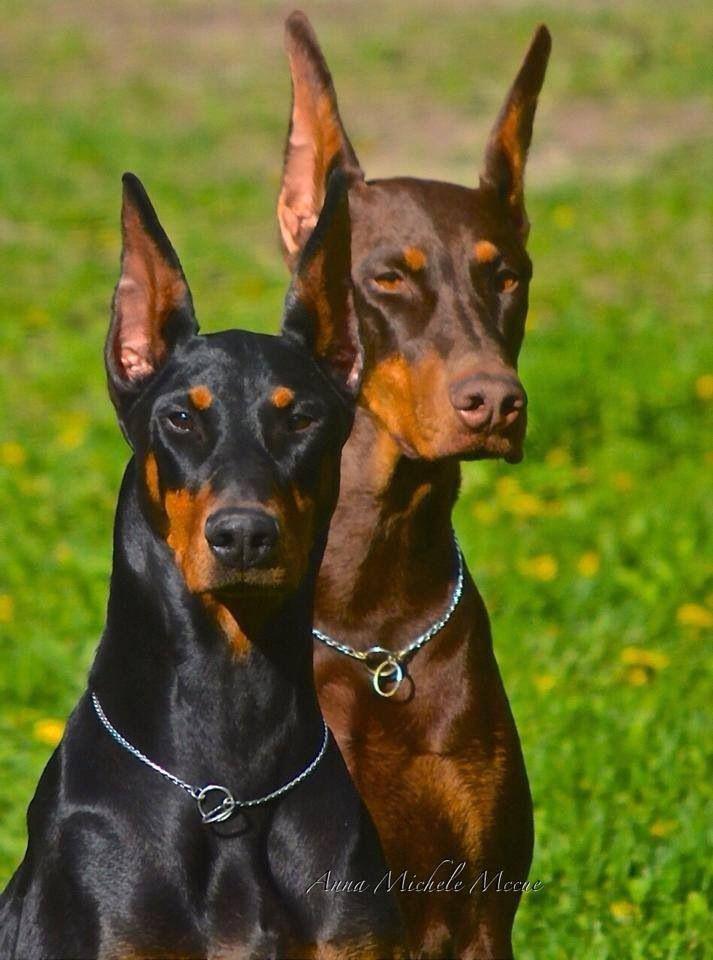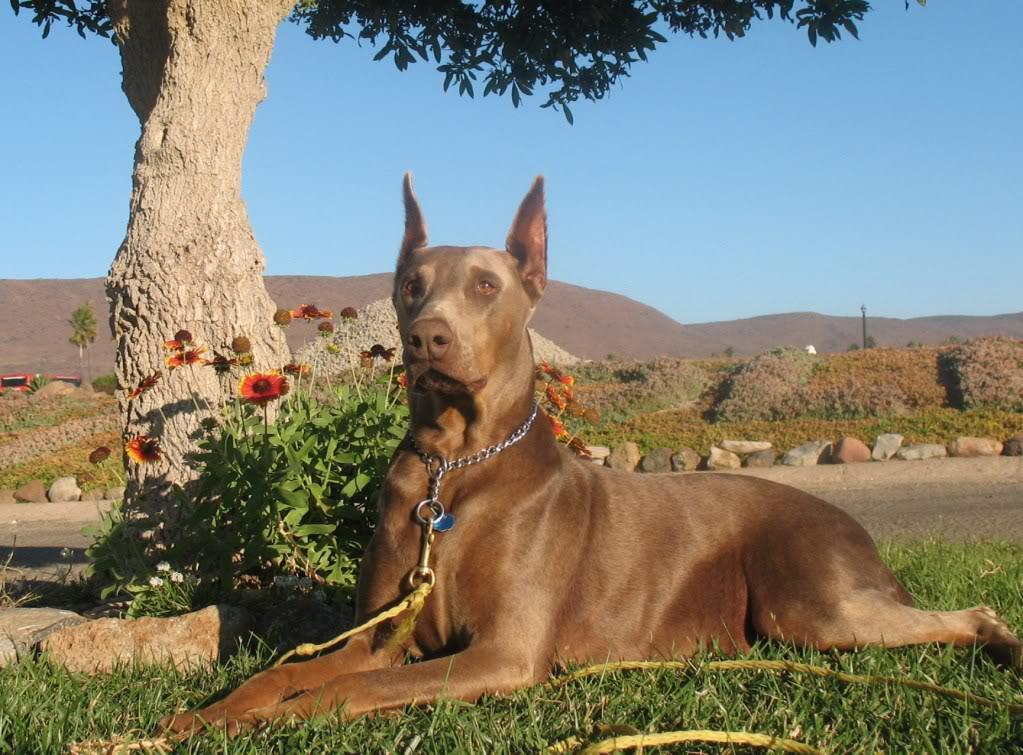The first image is the image on the left, the second image is the image on the right. Examine the images to the left and right. Is the description "At least one dog is lying down on the grass." accurate? Answer yes or no. Yes. 